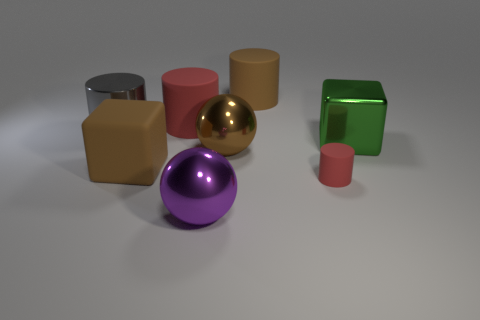Add 2 cyan cylinders. How many objects exist? 10 Subtract all cubes. How many objects are left? 6 Subtract 0 cyan cylinders. How many objects are left? 8 Subtract all big green cubes. Subtract all large purple objects. How many objects are left? 6 Add 8 big brown spheres. How many big brown spheres are left? 9 Add 4 large green cylinders. How many large green cylinders exist? 4 